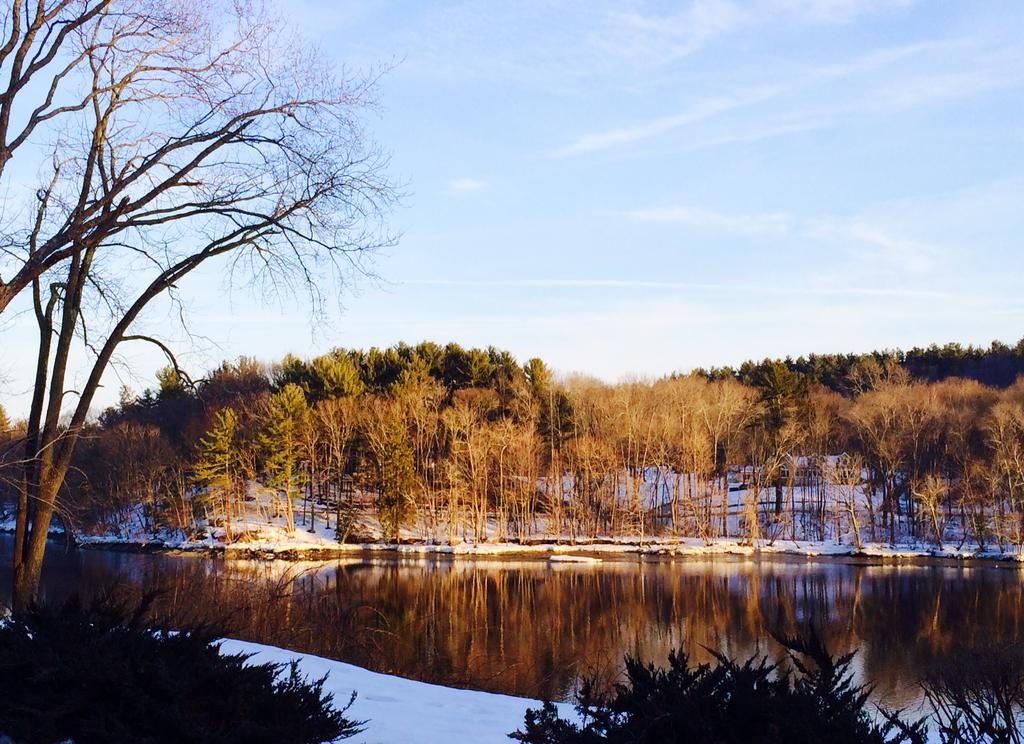What is present in the image that is not solid? There is water in the image. What type of vegetation can be seen in the image? There are trees in the image. What can be seen in the distance in the image? The sky is visible in the background of the image. What type of poisonous powder is visible in the image? There is no poisonous powder present in the image. What kind of flame can be seen in the image? There is no flame present in the image. 